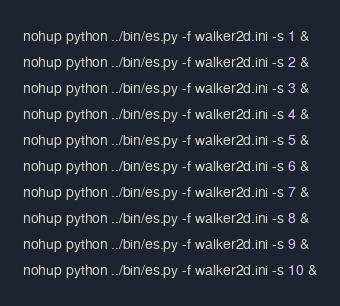<code> <loc_0><loc_0><loc_500><loc_500><_Bash_>nohup python ../bin/es.py -f walker2d.ini -s 1 &
nohup python ../bin/es.py -f walker2d.ini -s 2 &
nohup python ../bin/es.py -f walker2d.ini -s 3 &
nohup python ../bin/es.py -f walker2d.ini -s 4 &
nohup python ../bin/es.py -f walker2d.ini -s 5 &
nohup python ../bin/es.py -f walker2d.ini -s 6 &
nohup python ../bin/es.py -f walker2d.ini -s 7 &
nohup python ../bin/es.py -f walker2d.ini -s 8 &
nohup python ../bin/es.py -f walker2d.ini -s 9 &
nohup python ../bin/es.py -f walker2d.ini -s 10 &
</code> 